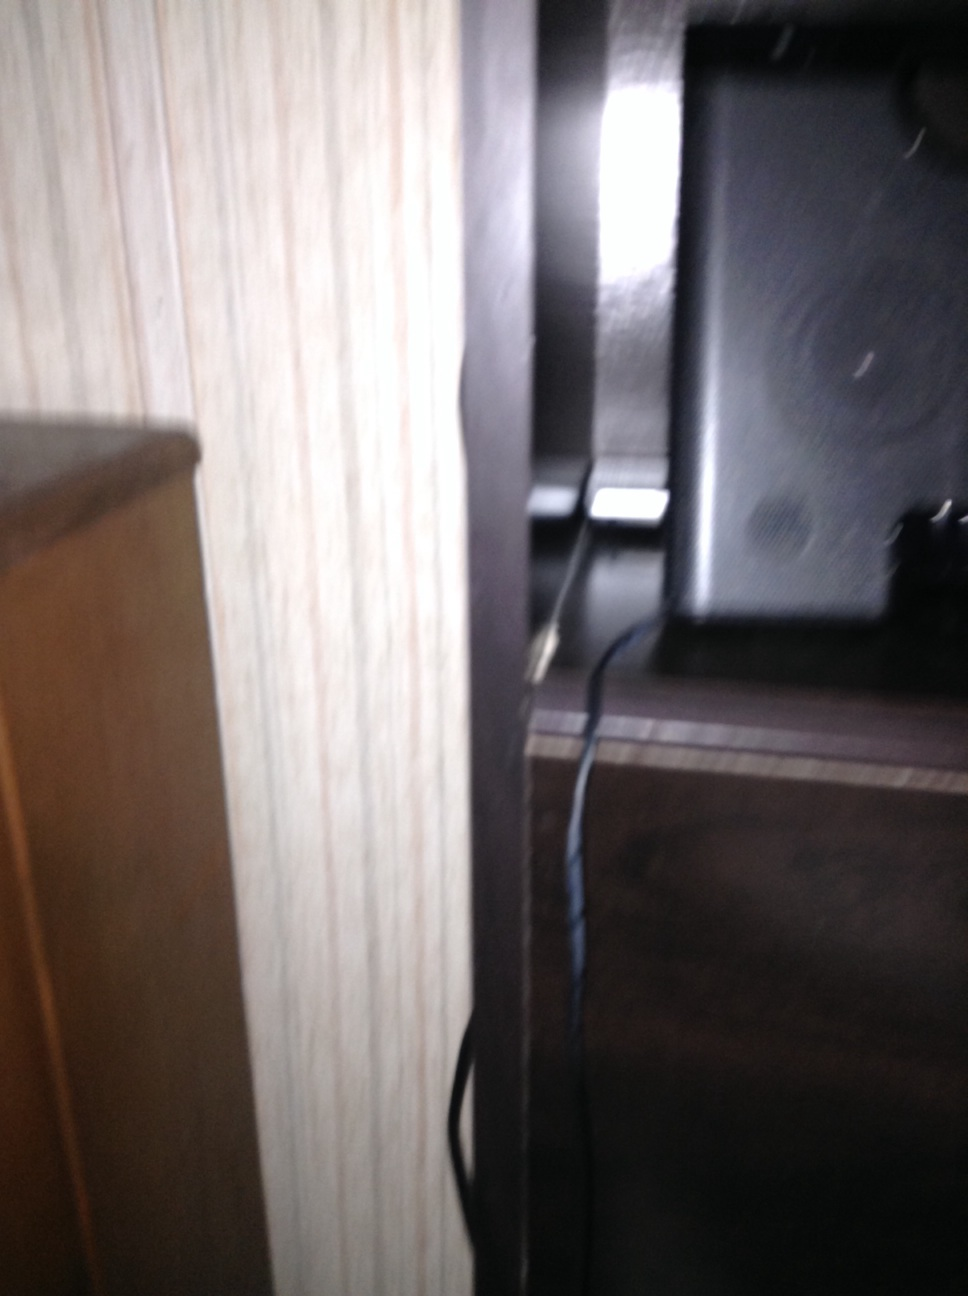What room do you think this is? This could be a part of a living room or a study area where audio equipment like a speaker is often set up. Can you describe the speaker in more detail? The speaker appears to be a standard bookshelf speaker with a rectangular shape, a visible round speaker driver, and a sleek, dark finish. It is connected to other devices through cables. 